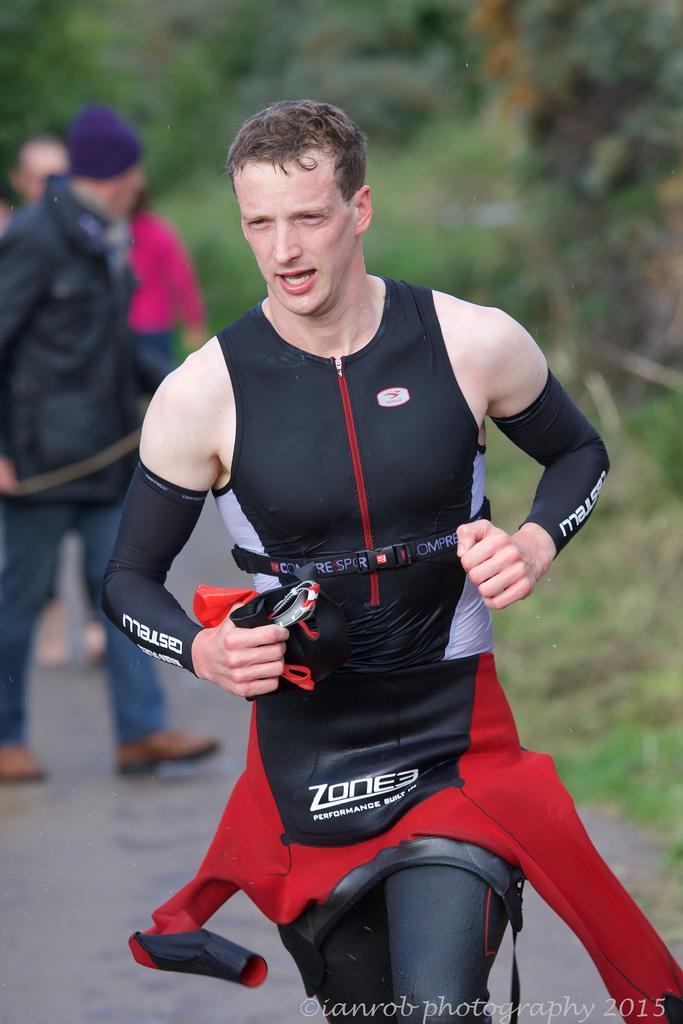Describe this image in one or two sentences. In the image there is a man in the foreground, it looks like he is running and behind him there are other people. 